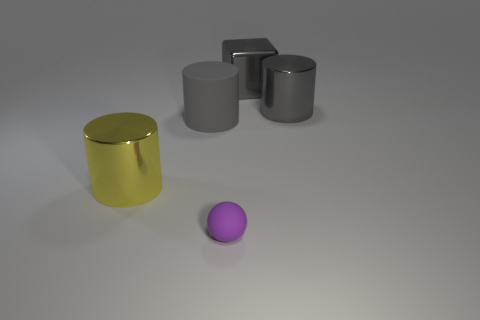What number of other rubber spheres are the same size as the rubber sphere?
Your response must be concise. 0. There is a cylinder right of the metallic block; what number of large yellow metal objects are on the left side of it?
Your response must be concise. 1. Is the material of the small object in front of the large metallic cube the same as the big yellow cylinder?
Make the answer very short. No. Is the material of the large cylinder right of the big metallic cube the same as the small purple sphere in front of the big gray block?
Ensure brevity in your answer.  No. Are there more tiny matte spheres that are behind the tiny purple thing than tiny rubber things?
Offer a terse response. No. What is the color of the shiny cylinder right of the matte object in front of the yellow cylinder?
Ensure brevity in your answer.  Gray. There is a gray rubber object that is the same size as the gray metallic cube; what shape is it?
Provide a succinct answer. Cylinder. Is the number of small green shiny balls the same as the number of metal blocks?
Your answer should be very brief. No. There is a large matte object that is the same color as the large metallic block; what shape is it?
Keep it short and to the point. Cylinder. Is the number of gray metal cubes on the left side of the gray matte cylinder the same as the number of small purple blocks?
Keep it short and to the point. Yes. 